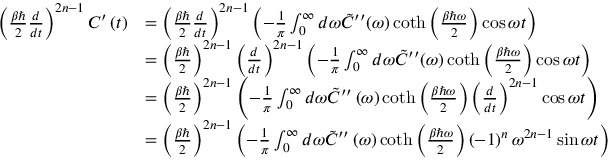<formula> <loc_0><loc_0><loc_500><loc_500>\begin{array} { r l } { \left ( \frac { \beta } { 2 } \frac { d } { d t } \right ) ^ { 2 n - 1 } C ^ { \prime } \left ( t \right ) } & { = \left ( \frac { \beta } { 2 } \frac { d } { d t } \right ) ^ { 2 n - 1 } \left ( - \frac { 1 } { \pi } \int _ { 0 } ^ { \infty } d \omega \tilde { C } ^ { \prime \prime } ( \omega ) \coth \left ( \frac { \beta \hbar { \omega } } { 2 } \right ) \cos \omega t \right ) } \\ & { = \left ( \frac { \beta } { 2 } \right ) ^ { 2 n - 1 } \left ( \frac { d } { d t } \right ) ^ { 2 n - 1 } \left ( - \frac { 1 } { \pi } \int _ { 0 } ^ { \infty } d \omega \tilde { C } ^ { \prime \prime } ( \omega ) \coth \left ( \frac { \beta \hbar { \omega } } { 2 } \right ) \cos \omega t \right ) } \\ & { = \left ( \frac { \beta } { 2 } \right ) ^ { 2 n - 1 } \left ( - \frac { 1 } { \pi } \int _ { 0 } ^ { \infty } d \omega \tilde { C } ^ { \prime \prime } \left ( \omega \right ) \coth \left ( \frac { \beta \hbar { \omega } } { 2 } \right ) \left ( \frac { d } { d t } \right ) ^ { 2 n - 1 } \cos \omega t \right ) } \\ & { = \left ( \frac { \beta } { 2 } \right ) ^ { 2 n - 1 } \left ( - \frac { 1 } { \pi } \int _ { 0 } ^ { \infty } d \omega \tilde { C } ^ { \prime \prime } \left ( \omega \right ) \coth \left ( \frac { \beta \hbar { \omega } } { 2 } \right ) \left ( - 1 \right ) ^ { n } \omega ^ { 2 n - 1 } \sin \omega t \right ) } \end{array}</formula> 